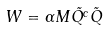<formula> <loc_0><loc_0><loc_500><loc_500>W = \alpha M \tilde { Q ^ { c } } \tilde { Q }</formula> 